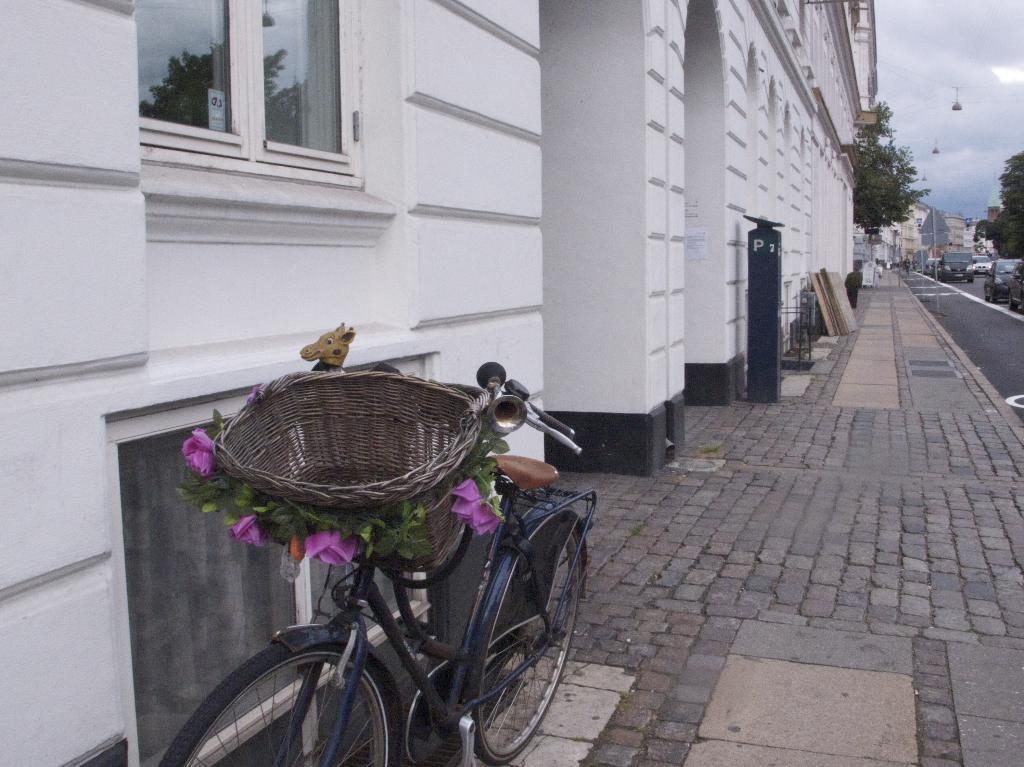In one or two sentences, can you explain what this image depicts? In this image we can see buildings, bicycles, motor vehicles on the road, sign boards, rope way, trees and sky with clouds. 